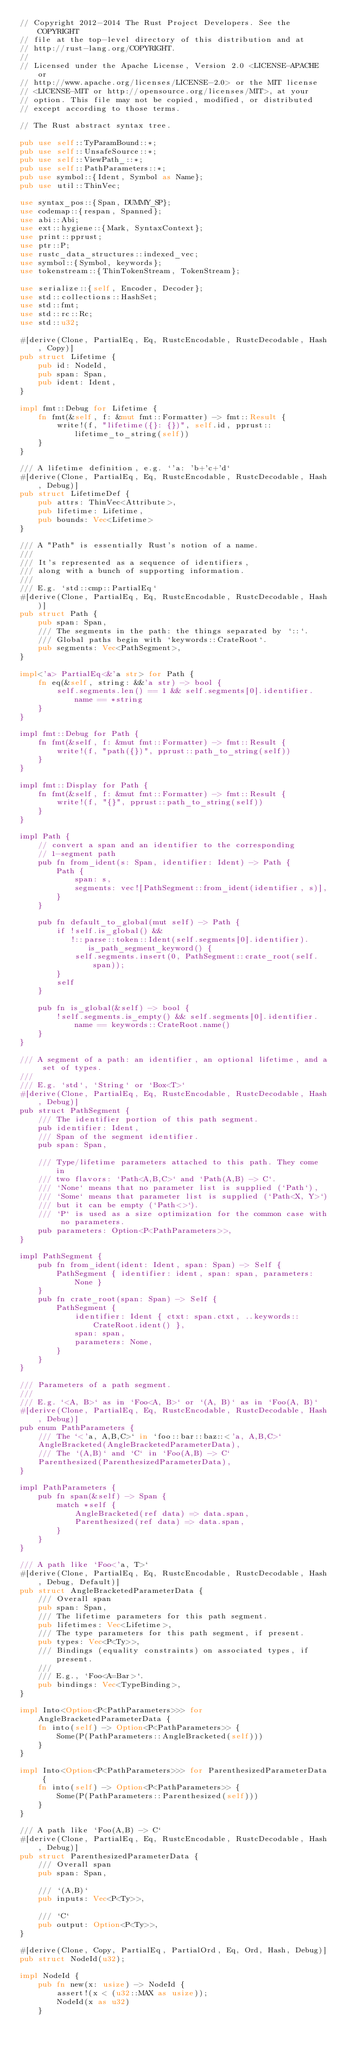<code> <loc_0><loc_0><loc_500><loc_500><_Rust_>// Copyright 2012-2014 The Rust Project Developers. See the COPYRIGHT
// file at the top-level directory of this distribution and at
// http://rust-lang.org/COPYRIGHT.
//
// Licensed under the Apache License, Version 2.0 <LICENSE-APACHE or
// http://www.apache.org/licenses/LICENSE-2.0> or the MIT license
// <LICENSE-MIT or http://opensource.org/licenses/MIT>, at your
// option. This file may not be copied, modified, or distributed
// except according to those terms.

// The Rust abstract syntax tree.

pub use self::TyParamBound::*;
pub use self::UnsafeSource::*;
pub use self::ViewPath_::*;
pub use self::PathParameters::*;
pub use symbol::{Ident, Symbol as Name};
pub use util::ThinVec;

use syntax_pos::{Span, DUMMY_SP};
use codemap::{respan, Spanned};
use abi::Abi;
use ext::hygiene::{Mark, SyntaxContext};
use print::pprust;
use ptr::P;
use rustc_data_structures::indexed_vec;
use symbol::{Symbol, keywords};
use tokenstream::{ThinTokenStream, TokenStream};

use serialize::{self, Encoder, Decoder};
use std::collections::HashSet;
use std::fmt;
use std::rc::Rc;
use std::u32;

#[derive(Clone, PartialEq, Eq, RustcEncodable, RustcDecodable, Hash, Copy)]
pub struct Lifetime {
    pub id: NodeId,
    pub span: Span,
    pub ident: Ident,
}

impl fmt::Debug for Lifetime {
    fn fmt(&self, f: &mut fmt::Formatter) -> fmt::Result {
        write!(f, "lifetime({}: {})", self.id, pprust::lifetime_to_string(self))
    }
}

/// A lifetime definition, e.g. `'a: 'b+'c+'d`
#[derive(Clone, PartialEq, Eq, RustcEncodable, RustcDecodable, Hash, Debug)]
pub struct LifetimeDef {
    pub attrs: ThinVec<Attribute>,
    pub lifetime: Lifetime,
    pub bounds: Vec<Lifetime>
}

/// A "Path" is essentially Rust's notion of a name.
///
/// It's represented as a sequence of identifiers,
/// along with a bunch of supporting information.
///
/// E.g. `std::cmp::PartialEq`
#[derive(Clone, PartialEq, Eq, RustcEncodable, RustcDecodable, Hash)]
pub struct Path {
    pub span: Span,
    /// The segments in the path: the things separated by `::`.
    /// Global paths begin with `keywords::CrateRoot`.
    pub segments: Vec<PathSegment>,
}

impl<'a> PartialEq<&'a str> for Path {
    fn eq(&self, string: &&'a str) -> bool {
        self.segments.len() == 1 && self.segments[0].identifier.name == *string
    }
}

impl fmt::Debug for Path {
    fn fmt(&self, f: &mut fmt::Formatter) -> fmt::Result {
        write!(f, "path({})", pprust::path_to_string(self))
    }
}

impl fmt::Display for Path {
    fn fmt(&self, f: &mut fmt::Formatter) -> fmt::Result {
        write!(f, "{}", pprust::path_to_string(self))
    }
}

impl Path {
    // convert a span and an identifier to the corresponding
    // 1-segment path
    pub fn from_ident(s: Span, identifier: Ident) -> Path {
        Path {
            span: s,
            segments: vec![PathSegment::from_ident(identifier, s)],
        }
    }

    pub fn default_to_global(mut self) -> Path {
        if !self.is_global() &&
           !::parse::token::Ident(self.segments[0].identifier).is_path_segment_keyword() {
            self.segments.insert(0, PathSegment::crate_root(self.span));
        }
        self
    }

    pub fn is_global(&self) -> bool {
        !self.segments.is_empty() && self.segments[0].identifier.name == keywords::CrateRoot.name()
    }
}

/// A segment of a path: an identifier, an optional lifetime, and a set of types.
///
/// E.g. `std`, `String` or `Box<T>`
#[derive(Clone, PartialEq, Eq, RustcEncodable, RustcDecodable, Hash, Debug)]
pub struct PathSegment {
    /// The identifier portion of this path segment.
    pub identifier: Ident,
    /// Span of the segment identifier.
    pub span: Span,

    /// Type/lifetime parameters attached to this path. They come in
    /// two flavors: `Path<A,B,C>` and `Path(A,B) -> C`.
    /// `None` means that no parameter list is supplied (`Path`),
    /// `Some` means that parameter list is supplied (`Path<X, Y>`)
    /// but it can be empty (`Path<>`).
    /// `P` is used as a size optimization for the common case with no parameters.
    pub parameters: Option<P<PathParameters>>,
}

impl PathSegment {
    pub fn from_ident(ident: Ident, span: Span) -> Self {
        PathSegment { identifier: ident, span: span, parameters: None }
    }
    pub fn crate_root(span: Span) -> Self {
        PathSegment {
            identifier: Ident { ctxt: span.ctxt, ..keywords::CrateRoot.ident() },
            span: span,
            parameters: None,
        }
    }
}

/// Parameters of a path segment.
///
/// E.g. `<A, B>` as in `Foo<A, B>` or `(A, B)` as in `Foo(A, B)`
#[derive(Clone, PartialEq, Eq, RustcEncodable, RustcDecodable, Hash, Debug)]
pub enum PathParameters {
    /// The `<'a, A,B,C>` in `foo::bar::baz::<'a, A,B,C>`
    AngleBracketed(AngleBracketedParameterData),
    /// The `(A,B)` and `C` in `Foo(A,B) -> C`
    Parenthesized(ParenthesizedParameterData),
}

impl PathParameters {
    pub fn span(&self) -> Span {
        match *self {
            AngleBracketed(ref data) => data.span,
            Parenthesized(ref data) => data.span,
        }
    }
}

/// A path like `Foo<'a, T>`
#[derive(Clone, PartialEq, Eq, RustcEncodable, RustcDecodable, Hash, Debug, Default)]
pub struct AngleBracketedParameterData {
    /// Overall span
    pub span: Span,
    /// The lifetime parameters for this path segment.
    pub lifetimes: Vec<Lifetime>,
    /// The type parameters for this path segment, if present.
    pub types: Vec<P<Ty>>,
    /// Bindings (equality constraints) on associated types, if present.
    ///
    /// E.g., `Foo<A=Bar>`.
    pub bindings: Vec<TypeBinding>,
}

impl Into<Option<P<PathParameters>>> for AngleBracketedParameterData {
    fn into(self) -> Option<P<PathParameters>> {
        Some(P(PathParameters::AngleBracketed(self)))
    }
}

impl Into<Option<P<PathParameters>>> for ParenthesizedParameterData {
    fn into(self) -> Option<P<PathParameters>> {
        Some(P(PathParameters::Parenthesized(self)))
    }
}

/// A path like `Foo(A,B) -> C`
#[derive(Clone, PartialEq, Eq, RustcEncodable, RustcDecodable, Hash, Debug)]
pub struct ParenthesizedParameterData {
    /// Overall span
    pub span: Span,

    /// `(A,B)`
    pub inputs: Vec<P<Ty>>,

    /// `C`
    pub output: Option<P<Ty>>,
}

#[derive(Clone, Copy, PartialEq, PartialOrd, Eq, Ord, Hash, Debug)]
pub struct NodeId(u32);

impl NodeId {
    pub fn new(x: usize) -> NodeId {
        assert!(x < (u32::MAX as usize));
        NodeId(x as u32)
    }
</code> 